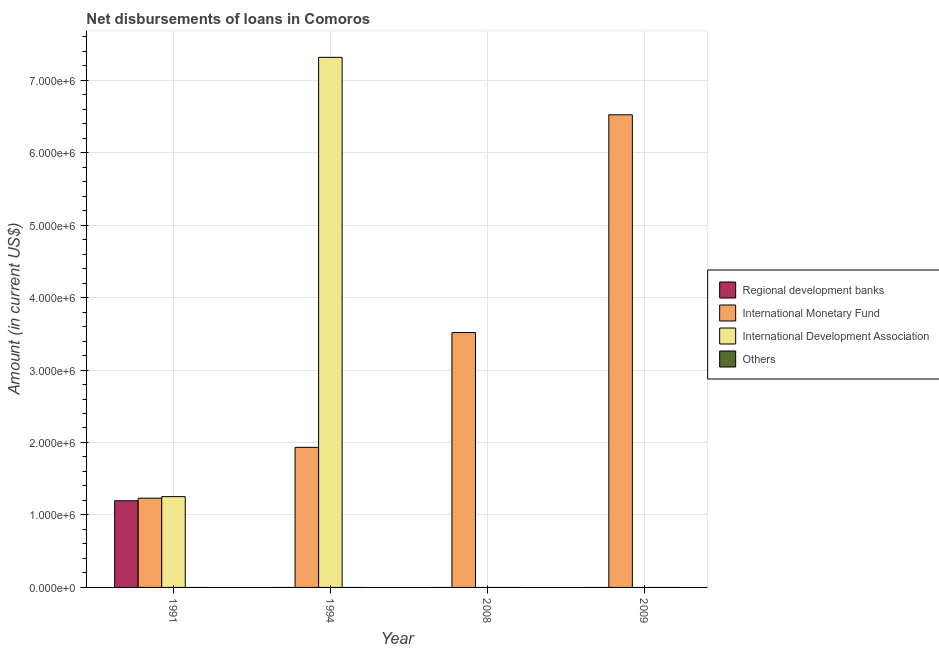How many different coloured bars are there?
Give a very brief answer. 3. Are the number of bars on each tick of the X-axis equal?
Offer a terse response. No. How many bars are there on the 2nd tick from the left?
Ensure brevity in your answer.  2. Across all years, what is the maximum amount of loan disimbursed by international monetary fund?
Your answer should be very brief. 6.52e+06. Across all years, what is the minimum amount of loan disimbursed by regional development banks?
Offer a terse response. 0. What is the total amount of loan disimbursed by regional development banks in the graph?
Offer a very short reply. 1.20e+06. What is the difference between the amount of loan disimbursed by international monetary fund in 1991 and that in 1994?
Your answer should be compact. -7.01e+05. What is the difference between the amount of loan disimbursed by regional development banks in 1991 and the amount of loan disimbursed by other organisations in 2009?
Ensure brevity in your answer.  1.20e+06. In the year 2008, what is the difference between the amount of loan disimbursed by international monetary fund and amount of loan disimbursed by international development association?
Make the answer very short. 0. What is the ratio of the amount of loan disimbursed by international monetary fund in 1991 to that in 2008?
Your answer should be compact. 0.35. Is the difference between the amount of loan disimbursed by international monetary fund in 1991 and 1994 greater than the difference between the amount of loan disimbursed by international development association in 1991 and 1994?
Keep it short and to the point. No. What is the difference between the highest and the second highest amount of loan disimbursed by international monetary fund?
Make the answer very short. 3.00e+06. What is the difference between the highest and the lowest amount of loan disimbursed by international monetary fund?
Offer a terse response. 5.29e+06. In how many years, is the amount of loan disimbursed by other organisations greater than the average amount of loan disimbursed by other organisations taken over all years?
Your answer should be very brief. 0. Is the sum of the amount of loan disimbursed by international monetary fund in 1991 and 2009 greater than the maximum amount of loan disimbursed by other organisations across all years?
Your answer should be very brief. Yes. Is it the case that in every year, the sum of the amount of loan disimbursed by international development association and amount of loan disimbursed by other organisations is greater than the sum of amount of loan disimbursed by regional development banks and amount of loan disimbursed by international monetary fund?
Your response must be concise. No. Is it the case that in every year, the sum of the amount of loan disimbursed by regional development banks and amount of loan disimbursed by international monetary fund is greater than the amount of loan disimbursed by international development association?
Provide a succinct answer. No. How many years are there in the graph?
Ensure brevity in your answer.  4. What is the difference between two consecutive major ticks on the Y-axis?
Your answer should be compact. 1.00e+06. Where does the legend appear in the graph?
Keep it short and to the point. Center right. What is the title of the graph?
Offer a terse response. Net disbursements of loans in Comoros. Does "Public sector management" appear as one of the legend labels in the graph?
Ensure brevity in your answer.  No. What is the label or title of the X-axis?
Provide a short and direct response. Year. What is the label or title of the Y-axis?
Offer a terse response. Amount (in current US$). What is the Amount (in current US$) in Regional development banks in 1991?
Offer a terse response. 1.20e+06. What is the Amount (in current US$) in International Monetary Fund in 1991?
Offer a terse response. 1.23e+06. What is the Amount (in current US$) in International Development Association in 1991?
Your answer should be very brief. 1.25e+06. What is the Amount (in current US$) of Others in 1991?
Keep it short and to the point. 0. What is the Amount (in current US$) in International Monetary Fund in 1994?
Your answer should be compact. 1.93e+06. What is the Amount (in current US$) of International Development Association in 1994?
Offer a very short reply. 7.32e+06. What is the Amount (in current US$) of Regional development banks in 2008?
Your answer should be compact. 0. What is the Amount (in current US$) in International Monetary Fund in 2008?
Your answer should be compact. 3.52e+06. What is the Amount (in current US$) of Regional development banks in 2009?
Offer a very short reply. 0. What is the Amount (in current US$) in International Monetary Fund in 2009?
Keep it short and to the point. 6.52e+06. Across all years, what is the maximum Amount (in current US$) of Regional development banks?
Your answer should be compact. 1.20e+06. Across all years, what is the maximum Amount (in current US$) of International Monetary Fund?
Provide a short and direct response. 6.52e+06. Across all years, what is the maximum Amount (in current US$) in International Development Association?
Your answer should be very brief. 7.32e+06. Across all years, what is the minimum Amount (in current US$) of Regional development banks?
Your response must be concise. 0. Across all years, what is the minimum Amount (in current US$) in International Monetary Fund?
Offer a terse response. 1.23e+06. What is the total Amount (in current US$) in Regional development banks in the graph?
Provide a short and direct response. 1.20e+06. What is the total Amount (in current US$) in International Monetary Fund in the graph?
Your answer should be very brief. 1.32e+07. What is the total Amount (in current US$) of International Development Association in the graph?
Provide a succinct answer. 8.57e+06. What is the difference between the Amount (in current US$) of International Monetary Fund in 1991 and that in 1994?
Keep it short and to the point. -7.01e+05. What is the difference between the Amount (in current US$) of International Development Association in 1991 and that in 1994?
Make the answer very short. -6.06e+06. What is the difference between the Amount (in current US$) in International Monetary Fund in 1991 and that in 2008?
Keep it short and to the point. -2.28e+06. What is the difference between the Amount (in current US$) in International Monetary Fund in 1991 and that in 2009?
Ensure brevity in your answer.  -5.29e+06. What is the difference between the Amount (in current US$) in International Monetary Fund in 1994 and that in 2008?
Provide a short and direct response. -1.58e+06. What is the difference between the Amount (in current US$) of International Monetary Fund in 1994 and that in 2009?
Make the answer very short. -4.59e+06. What is the difference between the Amount (in current US$) of International Monetary Fund in 2008 and that in 2009?
Offer a terse response. -3.00e+06. What is the difference between the Amount (in current US$) of Regional development banks in 1991 and the Amount (in current US$) of International Monetary Fund in 1994?
Keep it short and to the point. -7.37e+05. What is the difference between the Amount (in current US$) in Regional development banks in 1991 and the Amount (in current US$) in International Development Association in 1994?
Keep it short and to the point. -6.12e+06. What is the difference between the Amount (in current US$) of International Monetary Fund in 1991 and the Amount (in current US$) of International Development Association in 1994?
Provide a succinct answer. -6.08e+06. What is the difference between the Amount (in current US$) of Regional development banks in 1991 and the Amount (in current US$) of International Monetary Fund in 2008?
Your answer should be compact. -2.32e+06. What is the difference between the Amount (in current US$) of Regional development banks in 1991 and the Amount (in current US$) of International Monetary Fund in 2009?
Your response must be concise. -5.33e+06. What is the average Amount (in current US$) in Regional development banks per year?
Offer a terse response. 2.99e+05. What is the average Amount (in current US$) of International Monetary Fund per year?
Offer a terse response. 3.30e+06. What is the average Amount (in current US$) of International Development Association per year?
Provide a succinct answer. 2.14e+06. In the year 1991, what is the difference between the Amount (in current US$) of Regional development banks and Amount (in current US$) of International Monetary Fund?
Your answer should be very brief. -3.60e+04. In the year 1991, what is the difference between the Amount (in current US$) in Regional development banks and Amount (in current US$) in International Development Association?
Ensure brevity in your answer.  -5.70e+04. In the year 1991, what is the difference between the Amount (in current US$) of International Monetary Fund and Amount (in current US$) of International Development Association?
Make the answer very short. -2.10e+04. In the year 1994, what is the difference between the Amount (in current US$) of International Monetary Fund and Amount (in current US$) of International Development Association?
Provide a succinct answer. -5.38e+06. What is the ratio of the Amount (in current US$) of International Monetary Fund in 1991 to that in 1994?
Give a very brief answer. 0.64. What is the ratio of the Amount (in current US$) in International Development Association in 1991 to that in 1994?
Provide a succinct answer. 0.17. What is the ratio of the Amount (in current US$) in International Monetary Fund in 1991 to that in 2008?
Offer a very short reply. 0.35. What is the ratio of the Amount (in current US$) in International Monetary Fund in 1991 to that in 2009?
Offer a terse response. 0.19. What is the ratio of the Amount (in current US$) of International Monetary Fund in 1994 to that in 2008?
Offer a very short reply. 0.55. What is the ratio of the Amount (in current US$) in International Monetary Fund in 1994 to that in 2009?
Offer a very short reply. 0.3. What is the ratio of the Amount (in current US$) in International Monetary Fund in 2008 to that in 2009?
Your answer should be compact. 0.54. What is the difference between the highest and the second highest Amount (in current US$) in International Monetary Fund?
Offer a terse response. 3.00e+06. What is the difference between the highest and the lowest Amount (in current US$) of Regional development banks?
Offer a very short reply. 1.20e+06. What is the difference between the highest and the lowest Amount (in current US$) in International Monetary Fund?
Give a very brief answer. 5.29e+06. What is the difference between the highest and the lowest Amount (in current US$) in International Development Association?
Provide a succinct answer. 7.32e+06. 